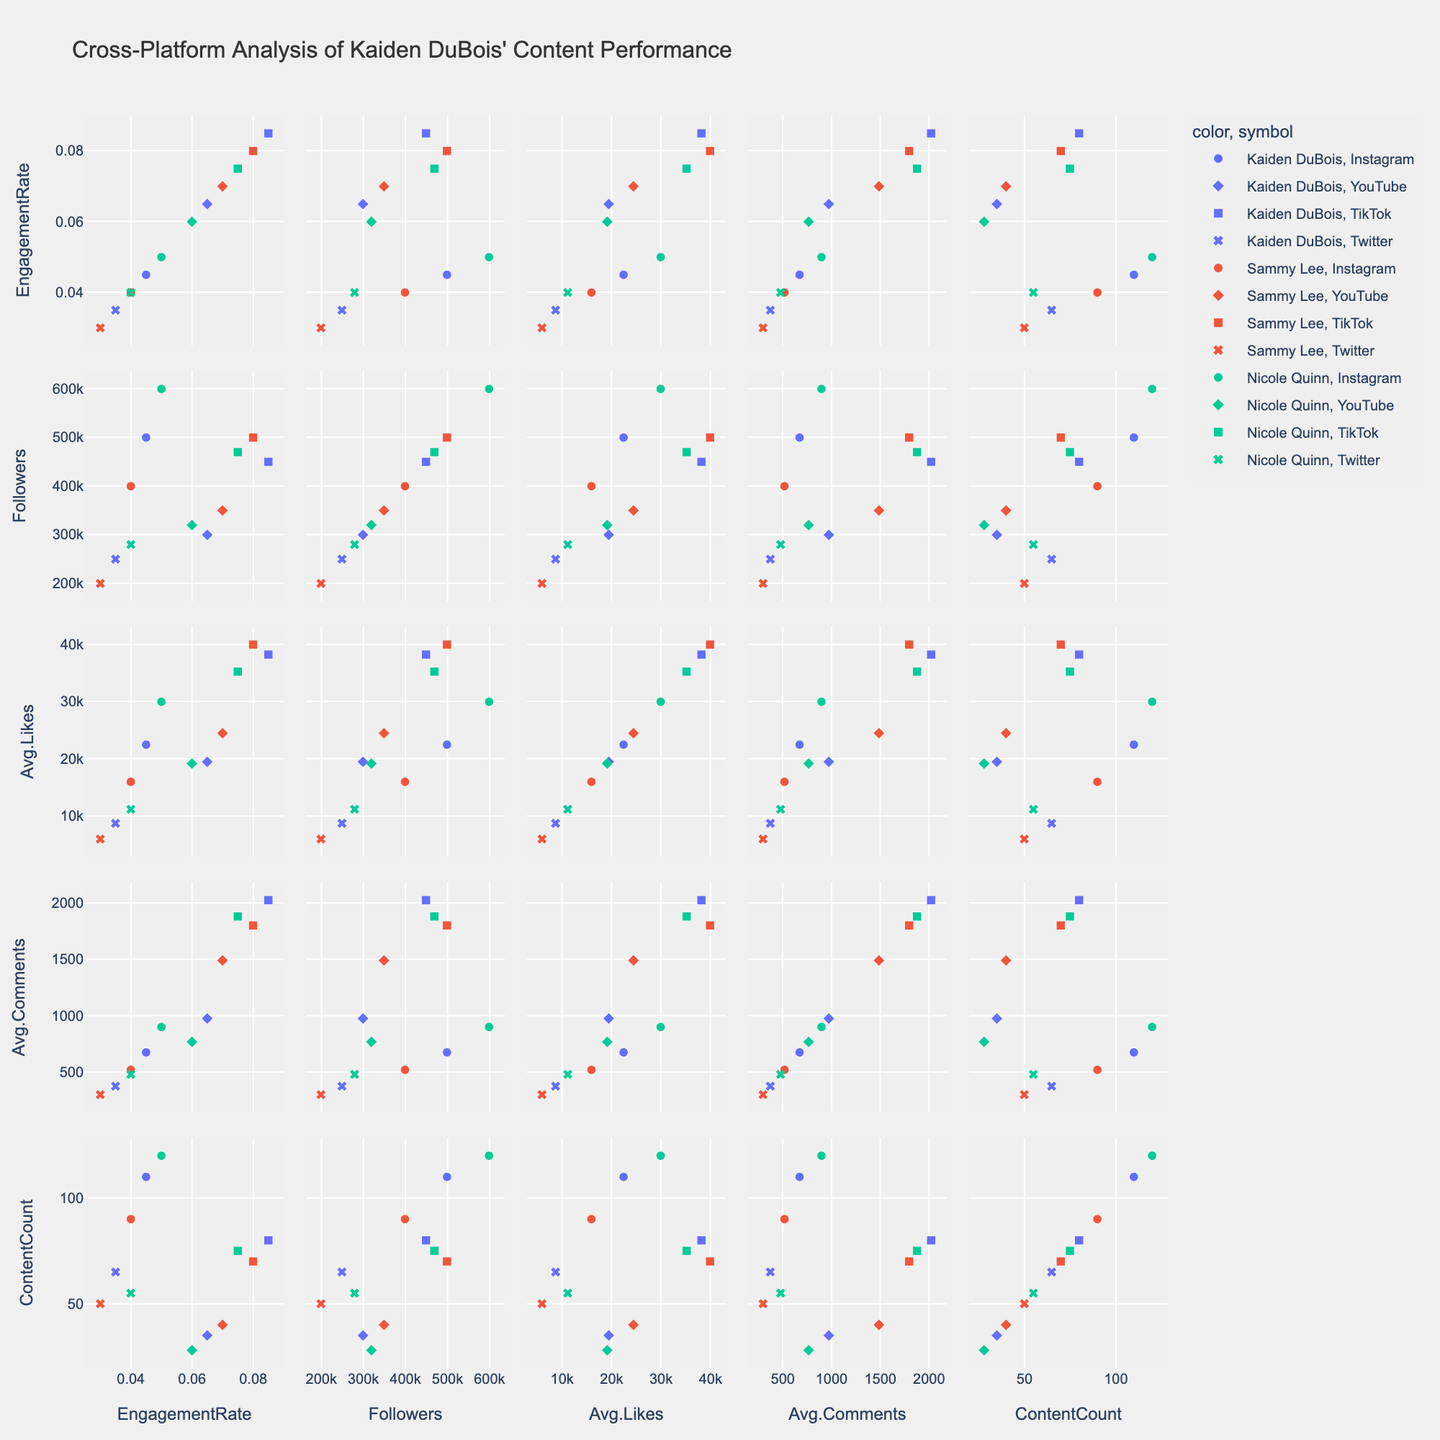What are the platforms displayed in the scatter plot matrix? The scatter plot matrix uses different symbols to represent each platform. By looking at the symbols and the legend, we can identify Instagram, YouTube, TikTok, and Twitter.
Answer: Instagram, YouTube, TikTok, Twitter Which influencer has the highest engagement rate on TikTok? By locating the TikTok symbol and checking the engagement rates, we find that Kaiden DuBois has the highest engagement rate on TikTok at 0.085.
Answer: Kaiden DuBois What is the median content count for Kaiden DuBois across all platforms? The content counts for Kaiden DuBois across Instagram (110), YouTube (35), TikTok (80), and Twitter (65) need to be ordered: 35, 65, 80, 110. The median is the average of the two middle numbers: (65+80)/2 = 72.5.
Answer: 72.5 Which platform has the highest average likes for Nicole Quinn? By finding Nicole Quinn in the legend and then examining the average likes across platforms, TikTok shows the highest value with 35250 average likes.
Answer: TikTok How does Sammy Lee's engagement rate on YouTube compare to Kaiden DuBois'? By comparing the engagement rates on YouTube for Sammy Lee (0.070) and Kaiden DuBois (0.065), Sammy Lee has a higher engagement rate.
Answer: Sammy Lee has a higher rate Can you identify any relationship between followers and average likes for all influencers? By looking at the scatter plots involving 'Followers' and 'AverageLikes', there seems to be a positive correlation where more followers generally lead to higher average likes.
Answer: Positive correlation What is the combined follower count for Kaiden DuBois across all platforms? The follower counts for Kaiden DuBois on Instagram (500000), YouTube (300000), TikTok (450000), and Twitter (250000) add up to: 500000 + 300000 + 450000 + 250000 = 1500000.
Answer: 1500000 Does Nicole Quinn have higher engagement rates on Instagram or Twitter? By comparing the engagement rates on Instagram (0.050) and Twitter (0.040) for Nicole Quinn, her engagement rate is higher on Instagram.
Answer: Instagram Which influencer has the lowest average comments on Twitter? By looking at the average comments on Twitter for each influencer, Sammy Lee has the lowest with 300 average comments.
Answer: Sammy Lee How does the content count on YouTube compare across all three influencers? By comparing the YouTube content counts for Kaiden DuBois (35), Sammy Lee (40), and Nicole Quinn (28). Sammy Lee has the highest, followed by Kaiden DuBois and then Nicole Quinn.
Answer: Sammy Lee > Kaiden DuBois > Nicole Quinn 